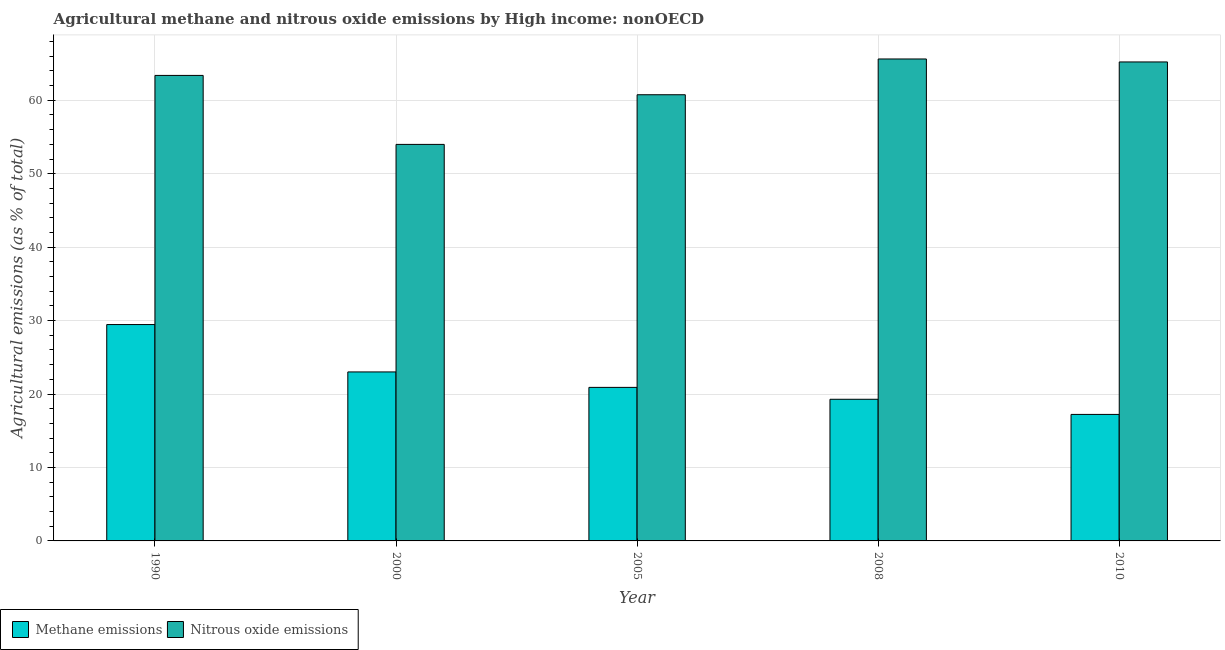How many different coloured bars are there?
Offer a terse response. 2. Are the number of bars per tick equal to the number of legend labels?
Provide a succinct answer. Yes. How many bars are there on the 2nd tick from the left?
Your response must be concise. 2. What is the label of the 2nd group of bars from the left?
Keep it short and to the point. 2000. What is the amount of methane emissions in 2000?
Give a very brief answer. 23.01. Across all years, what is the maximum amount of nitrous oxide emissions?
Offer a very short reply. 65.63. Across all years, what is the minimum amount of methane emissions?
Make the answer very short. 17.23. In which year was the amount of methane emissions maximum?
Offer a very short reply. 1990. What is the total amount of nitrous oxide emissions in the graph?
Your answer should be compact. 309. What is the difference between the amount of nitrous oxide emissions in 2008 and that in 2010?
Make the answer very short. 0.4. What is the difference between the amount of nitrous oxide emissions in 2008 and the amount of methane emissions in 2010?
Keep it short and to the point. 0.4. What is the average amount of methane emissions per year?
Provide a succinct answer. 21.98. In the year 1990, what is the difference between the amount of nitrous oxide emissions and amount of methane emissions?
Provide a short and direct response. 0. What is the ratio of the amount of nitrous oxide emissions in 2000 to that in 2005?
Your answer should be compact. 0.89. Is the amount of methane emissions in 1990 less than that in 2010?
Offer a terse response. No. Is the difference between the amount of methane emissions in 2000 and 2005 greater than the difference between the amount of nitrous oxide emissions in 2000 and 2005?
Give a very brief answer. No. What is the difference between the highest and the second highest amount of methane emissions?
Offer a terse response. 6.45. What is the difference between the highest and the lowest amount of nitrous oxide emissions?
Keep it short and to the point. 11.63. Is the sum of the amount of nitrous oxide emissions in 1990 and 2010 greater than the maximum amount of methane emissions across all years?
Provide a succinct answer. Yes. What does the 2nd bar from the left in 2000 represents?
Your answer should be very brief. Nitrous oxide emissions. What does the 2nd bar from the right in 2000 represents?
Offer a very short reply. Methane emissions. How many years are there in the graph?
Ensure brevity in your answer.  5. What is the difference between two consecutive major ticks on the Y-axis?
Your answer should be very brief. 10. Where does the legend appear in the graph?
Your response must be concise. Bottom left. What is the title of the graph?
Offer a terse response. Agricultural methane and nitrous oxide emissions by High income: nonOECD. What is the label or title of the Y-axis?
Offer a very short reply. Agricultural emissions (as % of total). What is the Agricultural emissions (as % of total) of Methane emissions in 1990?
Offer a very short reply. 29.46. What is the Agricultural emissions (as % of total) of Nitrous oxide emissions in 1990?
Provide a succinct answer. 63.39. What is the Agricultural emissions (as % of total) in Methane emissions in 2000?
Your response must be concise. 23.01. What is the Agricultural emissions (as % of total) of Nitrous oxide emissions in 2000?
Your answer should be very brief. 54. What is the Agricultural emissions (as % of total) of Methane emissions in 2005?
Your answer should be very brief. 20.91. What is the Agricultural emissions (as % of total) in Nitrous oxide emissions in 2005?
Your answer should be very brief. 60.76. What is the Agricultural emissions (as % of total) of Methane emissions in 2008?
Offer a very short reply. 19.29. What is the Agricultural emissions (as % of total) of Nitrous oxide emissions in 2008?
Your response must be concise. 65.63. What is the Agricultural emissions (as % of total) in Methane emissions in 2010?
Offer a very short reply. 17.23. What is the Agricultural emissions (as % of total) in Nitrous oxide emissions in 2010?
Make the answer very short. 65.22. Across all years, what is the maximum Agricultural emissions (as % of total) of Methane emissions?
Give a very brief answer. 29.46. Across all years, what is the maximum Agricultural emissions (as % of total) of Nitrous oxide emissions?
Provide a short and direct response. 65.63. Across all years, what is the minimum Agricultural emissions (as % of total) of Methane emissions?
Provide a succinct answer. 17.23. Across all years, what is the minimum Agricultural emissions (as % of total) in Nitrous oxide emissions?
Keep it short and to the point. 54. What is the total Agricultural emissions (as % of total) of Methane emissions in the graph?
Ensure brevity in your answer.  109.9. What is the total Agricultural emissions (as % of total) in Nitrous oxide emissions in the graph?
Your answer should be compact. 309. What is the difference between the Agricultural emissions (as % of total) in Methane emissions in 1990 and that in 2000?
Offer a terse response. 6.45. What is the difference between the Agricultural emissions (as % of total) in Nitrous oxide emissions in 1990 and that in 2000?
Provide a succinct answer. 9.39. What is the difference between the Agricultural emissions (as % of total) of Methane emissions in 1990 and that in 2005?
Give a very brief answer. 8.56. What is the difference between the Agricultural emissions (as % of total) in Nitrous oxide emissions in 1990 and that in 2005?
Offer a terse response. 2.63. What is the difference between the Agricultural emissions (as % of total) in Methane emissions in 1990 and that in 2008?
Provide a short and direct response. 10.17. What is the difference between the Agricultural emissions (as % of total) in Nitrous oxide emissions in 1990 and that in 2008?
Provide a short and direct response. -2.24. What is the difference between the Agricultural emissions (as % of total) of Methane emissions in 1990 and that in 2010?
Offer a terse response. 12.24. What is the difference between the Agricultural emissions (as % of total) of Nitrous oxide emissions in 1990 and that in 2010?
Offer a terse response. -1.83. What is the difference between the Agricultural emissions (as % of total) of Methane emissions in 2000 and that in 2005?
Your answer should be very brief. 2.1. What is the difference between the Agricultural emissions (as % of total) in Nitrous oxide emissions in 2000 and that in 2005?
Make the answer very short. -6.76. What is the difference between the Agricultural emissions (as % of total) of Methane emissions in 2000 and that in 2008?
Keep it short and to the point. 3.72. What is the difference between the Agricultural emissions (as % of total) of Nitrous oxide emissions in 2000 and that in 2008?
Your response must be concise. -11.63. What is the difference between the Agricultural emissions (as % of total) in Methane emissions in 2000 and that in 2010?
Provide a short and direct response. 5.78. What is the difference between the Agricultural emissions (as % of total) of Nitrous oxide emissions in 2000 and that in 2010?
Your answer should be very brief. -11.23. What is the difference between the Agricultural emissions (as % of total) of Methane emissions in 2005 and that in 2008?
Offer a terse response. 1.62. What is the difference between the Agricultural emissions (as % of total) of Nitrous oxide emissions in 2005 and that in 2008?
Provide a succinct answer. -4.87. What is the difference between the Agricultural emissions (as % of total) in Methane emissions in 2005 and that in 2010?
Your answer should be compact. 3.68. What is the difference between the Agricultural emissions (as % of total) of Nitrous oxide emissions in 2005 and that in 2010?
Your answer should be compact. -4.47. What is the difference between the Agricultural emissions (as % of total) in Methane emissions in 2008 and that in 2010?
Offer a very short reply. 2.06. What is the difference between the Agricultural emissions (as % of total) of Nitrous oxide emissions in 2008 and that in 2010?
Give a very brief answer. 0.4. What is the difference between the Agricultural emissions (as % of total) in Methane emissions in 1990 and the Agricultural emissions (as % of total) in Nitrous oxide emissions in 2000?
Keep it short and to the point. -24.53. What is the difference between the Agricultural emissions (as % of total) of Methane emissions in 1990 and the Agricultural emissions (as % of total) of Nitrous oxide emissions in 2005?
Provide a short and direct response. -31.3. What is the difference between the Agricultural emissions (as % of total) of Methane emissions in 1990 and the Agricultural emissions (as % of total) of Nitrous oxide emissions in 2008?
Provide a short and direct response. -36.17. What is the difference between the Agricultural emissions (as % of total) in Methane emissions in 1990 and the Agricultural emissions (as % of total) in Nitrous oxide emissions in 2010?
Offer a terse response. -35.76. What is the difference between the Agricultural emissions (as % of total) of Methane emissions in 2000 and the Agricultural emissions (as % of total) of Nitrous oxide emissions in 2005?
Give a very brief answer. -37.75. What is the difference between the Agricultural emissions (as % of total) of Methane emissions in 2000 and the Agricultural emissions (as % of total) of Nitrous oxide emissions in 2008?
Your answer should be very brief. -42.62. What is the difference between the Agricultural emissions (as % of total) of Methane emissions in 2000 and the Agricultural emissions (as % of total) of Nitrous oxide emissions in 2010?
Keep it short and to the point. -42.21. What is the difference between the Agricultural emissions (as % of total) in Methane emissions in 2005 and the Agricultural emissions (as % of total) in Nitrous oxide emissions in 2008?
Give a very brief answer. -44.72. What is the difference between the Agricultural emissions (as % of total) of Methane emissions in 2005 and the Agricultural emissions (as % of total) of Nitrous oxide emissions in 2010?
Ensure brevity in your answer.  -44.32. What is the difference between the Agricultural emissions (as % of total) of Methane emissions in 2008 and the Agricultural emissions (as % of total) of Nitrous oxide emissions in 2010?
Make the answer very short. -45.94. What is the average Agricultural emissions (as % of total) in Methane emissions per year?
Offer a terse response. 21.98. What is the average Agricultural emissions (as % of total) of Nitrous oxide emissions per year?
Provide a succinct answer. 61.8. In the year 1990, what is the difference between the Agricultural emissions (as % of total) in Methane emissions and Agricultural emissions (as % of total) in Nitrous oxide emissions?
Make the answer very short. -33.93. In the year 2000, what is the difference between the Agricultural emissions (as % of total) of Methane emissions and Agricultural emissions (as % of total) of Nitrous oxide emissions?
Give a very brief answer. -30.98. In the year 2005, what is the difference between the Agricultural emissions (as % of total) in Methane emissions and Agricultural emissions (as % of total) in Nitrous oxide emissions?
Offer a terse response. -39.85. In the year 2008, what is the difference between the Agricultural emissions (as % of total) of Methane emissions and Agricultural emissions (as % of total) of Nitrous oxide emissions?
Your answer should be compact. -46.34. In the year 2010, what is the difference between the Agricultural emissions (as % of total) in Methane emissions and Agricultural emissions (as % of total) in Nitrous oxide emissions?
Provide a succinct answer. -48. What is the ratio of the Agricultural emissions (as % of total) in Methane emissions in 1990 to that in 2000?
Keep it short and to the point. 1.28. What is the ratio of the Agricultural emissions (as % of total) in Nitrous oxide emissions in 1990 to that in 2000?
Your answer should be very brief. 1.17. What is the ratio of the Agricultural emissions (as % of total) in Methane emissions in 1990 to that in 2005?
Your answer should be compact. 1.41. What is the ratio of the Agricultural emissions (as % of total) in Nitrous oxide emissions in 1990 to that in 2005?
Provide a short and direct response. 1.04. What is the ratio of the Agricultural emissions (as % of total) of Methane emissions in 1990 to that in 2008?
Keep it short and to the point. 1.53. What is the ratio of the Agricultural emissions (as % of total) of Nitrous oxide emissions in 1990 to that in 2008?
Give a very brief answer. 0.97. What is the ratio of the Agricultural emissions (as % of total) of Methane emissions in 1990 to that in 2010?
Give a very brief answer. 1.71. What is the ratio of the Agricultural emissions (as % of total) of Nitrous oxide emissions in 1990 to that in 2010?
Offer a terse response. 0.97. What is the ratio of the Agricultural emissions (as % of total) of Methane emissions in 2000 to that in 2005?
Your response must be concise. 1.1. What is the ratio of the Agricultural emissions (as % of total) of Nitrous oxide emissions in 2000 to that in 2005?
Offer a very short reply. 0.89. What is the ratio of the Agricultural emissions (as % of total) in Methane emissions in 2000 to that in 2008?
Provide a short and direct response. 1.19. What is the ratio of the Agricultural emissions (as % of total) in Nitrous oxide emissions in 2000 to that in 2008?
Your answer should be compact. 0.82. What is the ratio of the Agricultural emissions (as % of total) in Methane emissions in 2000 to that in 2010?
Your response must be concise. 1.34. What is the ratio of the Agricultural emissions (as % of total) of Nitrous oxide emissions in 2000 to that in 2010?
Keep it short and to the point. 0.83. What is the ratio of the Agricultural emissions (as % of total) of Methane emissions in 2005 to that in 2008?
Offer a terse response. 1.08. What is the ratio of the Agricultural emissions (as % of total) in Nitrous oxide emissions in 2005 to that in 2008?
Give a very brief answer. 0.93. What is the ratio of the Agricultural emissions (as % of total) in Methane emissions in 2005 to that in 2010?
Keep it short and to the point. 1.21. What is the ratio of the Agricultural emissions (as % of total) in Nitrous oxide emissions in 2005 to that in 2010?
Provide a succinct answer. 0.93. What is the ratio of the Agricultural emissions (as % of total) of Methane emissions in 2008 to that in 2010?
Offer a very short reply. 1.12. What is the ratio of the Agricultural emissions (as % of total) in Nitrous oxide emissions in 2008 to that in 2010?
Ensure brevity in your answer.  1.01. What is the difference between the highest and the second highest Agricultural emissions (as % of total) of Methane emissions?
Offer a terse response. 6.45. What is the difference between the highest and the second highest Agricultural emissions (as % of total) in Nitrous oxide emissions?
Offer a terse response. 0.4. What is the difference between the highest and the lowest Agricultural emissions (as % of total) of Methane emissions?
Ensure brevity in your answer.  12.24. What is the difference between the highest and the lowest Agricultural emissions (as % of total) of Nitrous oxide emissions?
Ensure brevity in your answer.  11.63. 